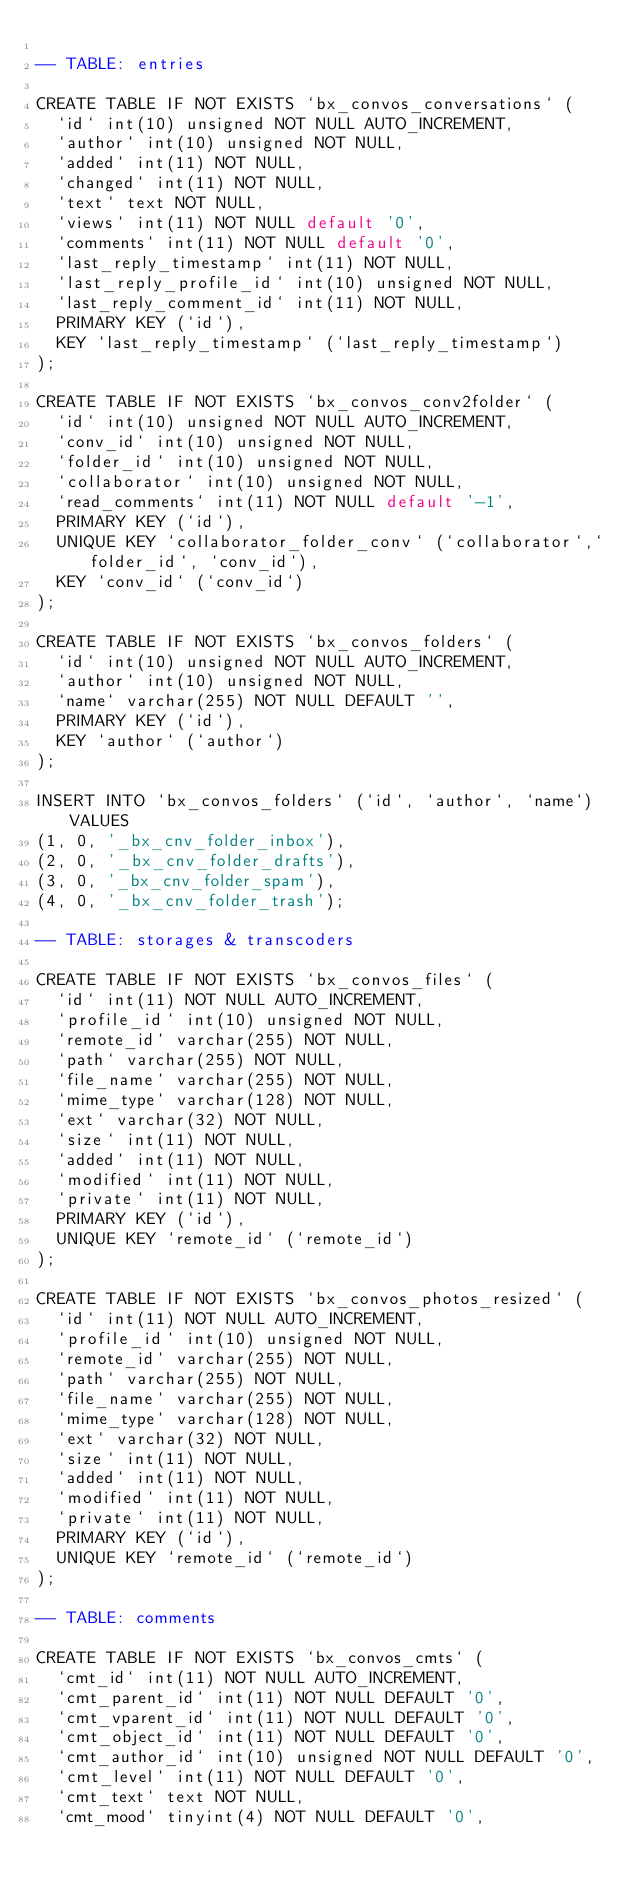Convert code to text. <code><loc_0><loc_0><loc_500><loc_500><_SQL_>
-- TABLE: entries

CREATE TABLE IF NOT EXISTS `bx_convos_conversations` (
  `id` int(10) unsigned NOT NULL AUTO_INCREMENT,
  `author` int(10) unsigned NOT NULL,
  `added` int(11) NOT NULL,
  `changed` int(11) NOT NULL,
  `text` text NOT NULL,
  `views` int(11) NOT NULL default '0',
  `comments` int(11) NOT NULL default '0',
  `last_reply_timestamp` int(11) NOT NULL,
  `last_reply_profile_id` int(10) unsigned NOT NULL,
  `last_reply_comment_id` int(11) NOT NULL,
  PRIMARY KEY (`id`),
  KEY `last_reply_timestamp` (`last_reply_timestamp`)
);

CREATE TABLE IF NOT EXISTS `bx_convos_conv2folder` (
  `id` int(10) unsigned NOT NULL AUTO_INCREMENT,
  `conv_id` int(10) unsigned NOT NULL,
  `folder_id` int(10) unsigned NOT NULL,
  `collaborator` int(10) unsigned NOT NULL,
  `read_comments` int(11) NOT NULL default '-1',
  PRIMARY KEY (`id`),
  UNIQUE KEY `collaborator_folder_conv` (`collaborator`,`folder_id`, `conv_id`),
  KEY `conv_id` (`conv_id`)
);

CREATE TABLE IF NOT EXISTS `bx_convos_folders` (
  `id` int(10) unsigned NOT NULL AUTO_INCREMENT,
  `author` int(10) unsigned NOT NULL,
  `name` varchar(255) NOT NULL DEFAULT '',
  PRIMARY KEY (`id`),
  KEY `author` (`author`)
);

INSERT INTO `bx_convos_folders` (`id`, `author`, `name`) VALUES
(1, 0, '_bx_cnv_folder_inbox'),
(2, 0, '_bx_cnv_folder_drafts'),
(3, 0, '_bx_cnv_folder_spam'),
(4, 0, '_bx_cnv_folder_trash');

-- TABLE: storages & transcoders

CREATE TABLE IF NOT EXISTS `bx_convos_files` (
  `id` int(11) NOT NULL AUTO_INCREMENT,
  `profile_id` int(10) unsigned NOT NULL,
  `remote_id` varchar(255) NOT NULL,
  `path` varchar(255) NOT NULL,
  `file_name` varchar(255) NOT NULL,
  `mime_type` varchar(128) NOT NULL,
  `ext` varchar(32) NOT NULL,
  `size` int(11) NOT NULL,
  `added` int(11) NOT NULL,
  `modified` int(11) NOT NULL,
  `private` int(11) NOT NULL,
  PRIMARY KEY (`id`),
  UNIQUE KEY `remote_id` (`remote_id`)
);

CREATE TABLE IF NOT EXISTS `bx_convos_photos_resized` (
  `id` int(11) NOT NULL AUTO_INCREMENT,
  `profile_id` int(10) unsigned NOT NULL,
  `remote_id` varchar(255) NOT NULL,
  `path` varchar(255) NOT NULL,
  `file_name` varchar(255) NOT NULL,
  `mime_type` varchar(128) NOT NULL,
  `ext` varchar(32) NOT NULL,
  `size` int(11) NOT NULL,
  `added` int(11) NOT NULL,
  `modified` int(11) NOT NULL,
  `private` int(11) NOT NULL,
  PRIMARY KEY (`id`),
  UNIQUE KEY `remote_id` (`remote_id`)
);

-- TABLE: comments

CREATE TABLE IF NOT EXISTS `bx_convos_cmts` (
  `cmt_id` int(11) NOT NULL AUTO_INCREMENT,
  `cmt_parent_id` int(11) NOT NULL DEFAULT '0',
  `cmt_vparent_id` int(11) NOT NULL DEFAULT '0',
  `cmt_object_id` int(11) NOT NULL DEFAULT '0',
  `cmt_author_id` int(10) unsigned NOT NULL DEFAULT '0',
  `cmt_level` int(11) NOT NULL DEFAULT '0',
  `cmt_text` text NOT NULL,
  `cmt_mood` tinyint(4) NOT NULL DEFAULT '0',</code> 